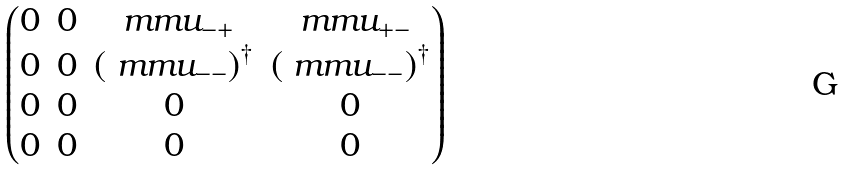<formula> <loc_0><loc_0><loc_500><loc_500>\begin{pmatrix} 0 & 0 & \ m m u _ { - + } & \ m m u _ { + - } \\ 0 & 0 & \left ( \ m m u _ { - - } \right ) ^ { \dag } & \left ( \ m m u _ { - - } \right ) ^ { \dag } \\ 0 & 0 & 0 & 0 \\ 0 & 0 & 0 & 0 \end{pmatrix}</formula> 